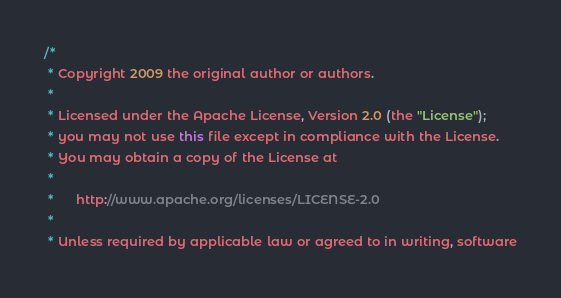<code> <loc_0><loc_0><loc_500><loc_500><_Java_>/*
 * Copyright 2009 the original author or authors.
 *
 * Licensed under the Apache License, Version 2.0 (the "License");
 * you may not use this file except in compliance with the License.
 * You may obtain a copy of the License at
 *
 *      http://www.apache.org/licenses/LICENSE-2.0
 *
 * Unless required by applicable law or agreed to in writing, software</code> 